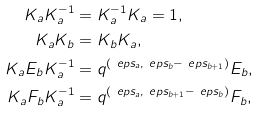<formula> <loc_0><loc_0><loc_500><loc_500>K _ { a } K _ { a } ^ { - 1 } & = K _ { a } ^ { - 1 } K _ { a } = 1 , \\ K _ { a } K _ { b } & = K _ { b } K _ { a } , \\ K _ { a } E _ { b } K _ { a } ^ { - 1 } & = q ^ { ( \ e p s _ { a } , \ e p s _ { b } - \ e p s _ { b + 1 } ) } E _ { b } , \\ K _ { a } F _ { b } K _ { a } ^ { - 1 } & = q ^ { ( \ e p s _ { a } , \ e p s _ { b + 1 } - \ e p s _ { b } ) } F _ { b } ,</formula> 